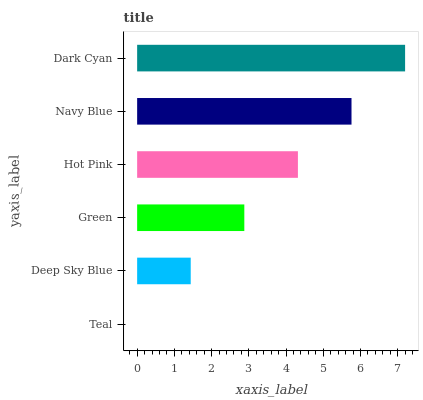Is Teal the minimum?
Answer yes or no. Yes. Is Dark Cyan the maximum?
Answer yes or no. Yes. Is Deep Sky Blue the minimum?
Answer yes or no. No. Is Deep Sky Blue the maximum?
Answer yes or no. No. Is Deep Sky Blue greater than Teal?
Answer yes or no. Yes. Is Teal less than Deep Sky Blue?
Answer yes or no. Yes. Is Teal greater than Deep Sky Blue?
Answer yes or no. No. Is Deep Sky Blue less than Teal?
Answer yes or no. No. Is Hot Pink the high median?
Answer yes or no. Yes. Is Green the low median?
Answer yes or no. Yes. Is Deep Sky Blue the high median?
Answer yes or no. No. Is Dark Cyan the low median?
Answer yes or no. No. 